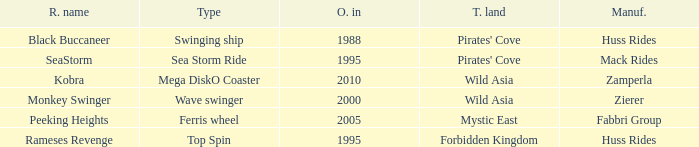What type of ride is Rameses Revenge? Top Spin. 